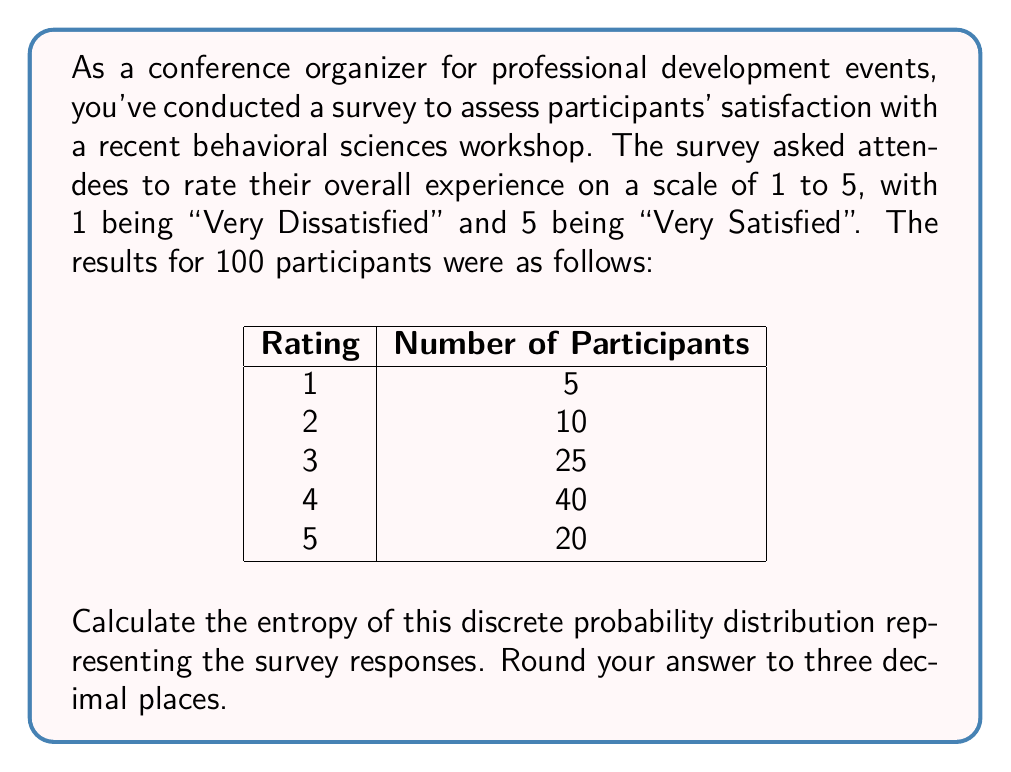Could you help me with this problem? To calculate the entropy of this discrete probability distribution, we'll follow these steps:

1. Calculate the probability for each rating:
   $p(1) = 5/100 = 0.05$
   $p(2) = 10/100 = 0.10$
   $p(3) = 25/100 = 0.25$
   $p(4) = 40/100 = 0.40$
   $p(5) = 20/100 = 0.20$

2. Use the entropy formula for a discrete probability distribution:
   $$H = -\sum_{i=1}^{n} p(x_i) \log_2(p(x_i))$$

3. Calculate each term in the sum:
   $-0.05 \log_2(0.05) \approx 0.2161$
   $-0.10 \log_2(0.10) \approx 0.3322$
   $-0.25 \log_2(0.25) \approx 0.5000$
   $-0.40 \log_2(0.40) \approx 0.5288$
   $-0.20 \log_2(0.20) \approx 0.4644$

4. Sum up all the terms:
   $H = 0.2161 + 0.3322 + 0.5000 + 0.5288 + 0.4644 = 2.0415$

5. Round the result to three decimal places:
   $H \approx 2.042$ bits

The entropy value of 2.042 bits indicates the average amount of information contained in each survey response. A higher entropy suggests more uncertainty or diversity in the responses, while a lower entropy would indicate more predictable or concentrated responses.
Answer: 2.042 bits 